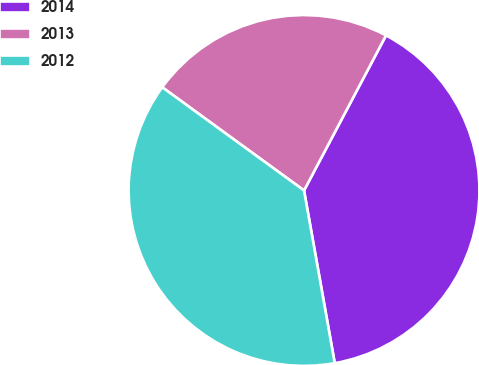Convert chart. <chart><loc_0><loc_0><loc_500><loc_500><pie_chart><fcel>2014<fcel>2013<fcel>2012<nl><fcel>39.46%<fcel>22.73%<fcel>37.82%<nl></chart> 